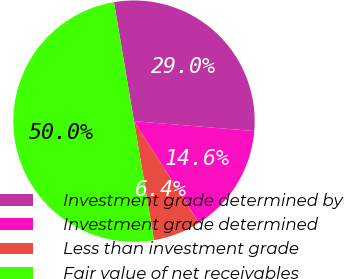Convert chart. <chart><loc_0><loc_0><loc_500><loc_500><pie_chart><fcel>Investment grade determined by<fcel>Investment grade determined<fcel>Less than investment grade<fcel>Fair value of net receivables<nl><fcel>28.96%<fcel>14.65%<fcel>6.39%<fcel>50.0%<nl></chart> 